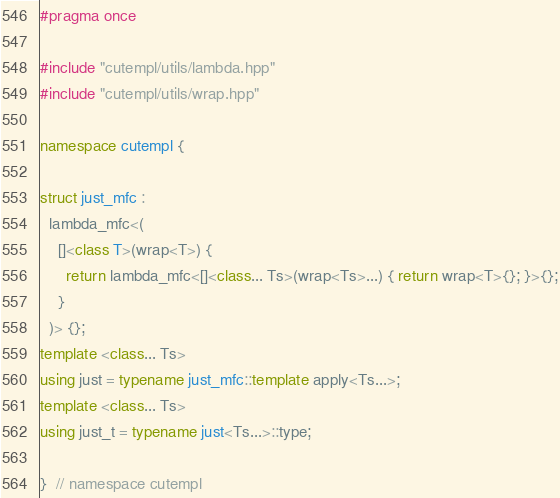Convert code to text. <code><loc_0><loc_0><loc_500><loc_500><_C++_>#pragma once

#include "cutempl/utils/lambda.hpp"
#include "cutempl/utils/wrap.hpp"

namespace cutempl {

struct just_mfc :
  lambda_mfc<(
    []<class T>(wrap<T>) {
      return lambda_mfc<[]<class... Ts>(wrap<Ts>...) { return wrap<T>{}; }>{};
    }
  )> {};
template <class... Ts>
using just = typename just_mfc::template apply<Ts...>;
template <class... Ts>
using just_t = typename just<Ts...>::type;

}  // namespace cutempl
</code> 